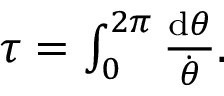<formula> <loc_0><loc_0><loc_500><loc_500>\begin{array} { r } { \tau = \int _ { 0 } ^ { 2 \pi } \frac { d \theta } { \dot { \theta } } . } \end{array}</formula> 